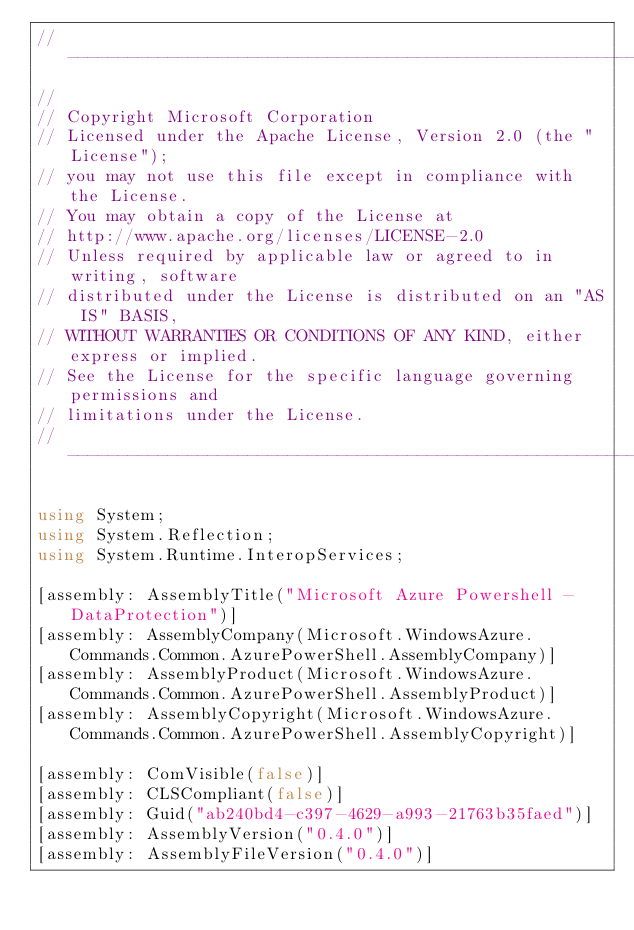<code> <loc_0><loc_0><loc_500><loc_500><_C#_>// ----------------------------------------------------------------------------------
//
// Copyright Microsoft Corporation
// Licensed under the Apache License, Version 2.0 (the "License");
// you may not use this file except in compliance with the License.
// You may obtain a copy of the License at
// http://www.apache.org/licenses/LICENSE-2.0
// Unless required by applicable law or agreed to in writing, software
// distributed under the License is distributed on an "AS IS" BASIS,
// WITHOUT WARRANTIES OR CONDITIONS OF ANY KIND, either express or implied.
// See the License for the specific language governing permissions and
// limitations under the License.
// ----------------------------------------------------------------------------------

using System;
using System.Reflection;
using System.Runtime.InteropServices;

[assembly: AssemblyTitle("Microsoft Azure Powershell - DataProtection")]
[assembly: AssemblyCompany(Microsoft.WindowsAzure.Commands.Common.AzurePowerShell.AssemblyCompany)]
[assembly: AssemblyProduct(Microsoft.WindowsAzure.Commands.Common.AzurePowerShell.AssemblyProduct)]
[assembly: AssemblyCopyright(Microsoft.WindowsAzure.Commands.Common.AzurePowerShell.AssemblyCopyright)]

[assembly: ComVisible(false)]
[assembly: CLSCompliant(false)]
[assembly: Guid("ab240bd4-c397-4629-a993-21763b35faed")]
[assembly: AssemblyVersion("0.4.0")]
[assembly: AssemblyFileVersion("0.4.0")]
</code> 